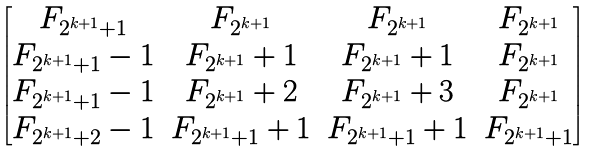<formula> <loc_0><loc_0><loc_500><loc_500>\begin{bmatrix} F _ { 2 ^ { k + 1 } + 1 } & F _ { 2 ^ { k + 1 } } & F _ { 2 ^ { k + 1 } } & F _ { 2 ^ { k + 1 } } \\ F _ { 2 ^ { k + 1 } + 1 } - 1 & F _ { 2 ^ { k + 1 } } + 1 & F _ { 2 ^ { k + 1 } } + 1 & F _ { 2 ^ { k + 1 } } \\ F _ { 2 ^ { k + 1 } + 1 } - 1 & F _ { 2 ^ { k + 1 } } + 2 & F _ { 2 ^ { k + 1 } } + 3 & F _ { 2 ^ { k + 1 } } \\ F _ { 2 ^ { k + 1 } + 2 } - 1 & F _ { 2 ^ { k + 1 } + 1 } + 1 & F _ { 2 ^ { k + 1 } + 1 } + 1 & F _ { 2 ^ { k + 1 } + 1 } \end{bmatrix}</formula> 